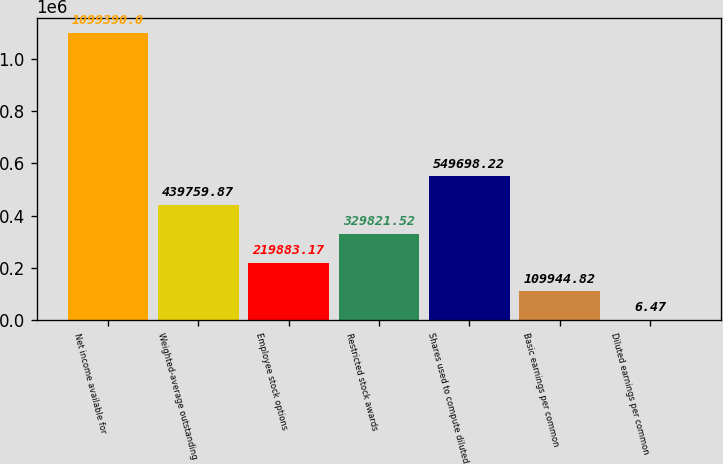Convert chart. <chart><loc_0><loc_0><loc_500><loc_500><bar_chart><fcel>Net income available for<fcel>Weighted-average outstanding<fcel>Employee stock options<fcel>Restricted stock awards<fcel>Shares used to compute diluted<fcel>Basic earnings per common<fcel>Diluted earnings per common<nl><fcel>1.09939e+06<fcel>439760<fcel>219883<fcel>329822<fcel>549698<fcel>109945<fcel>6.47<nl></chart> 